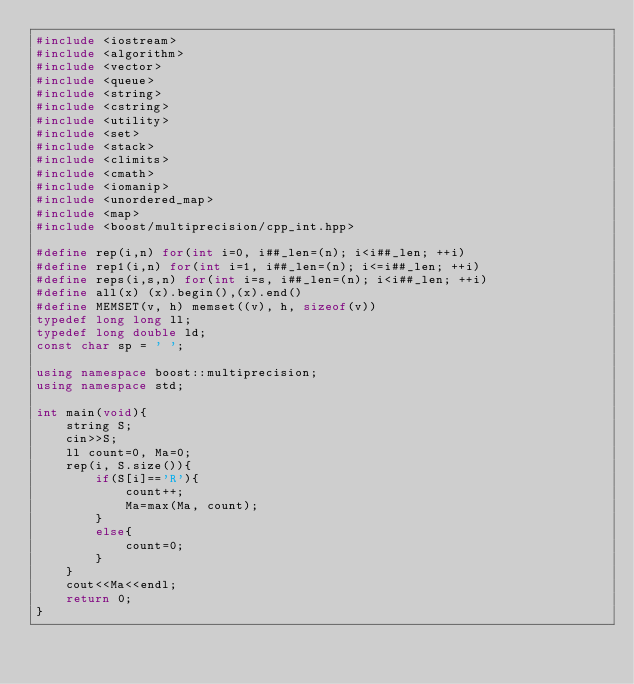<code> <loc_0><loc_0><loc_500><loc_500><_C++_>#include <iostream>
#include <algorithm>
#include <vector>
#include <queue>
#include <string>
#include <cstring>
#include <utility>
#include <set>
#include <stack>
#include <climits>
#include <cmath>
#include <iomanip>
#include <unordered_map>
#include <map>
#include <boost/multiprecision/cpp_int.hpp>

#define rep(i,n) for(int i=0, i##_len=(n); i<i##_len; ++i)
#define rep1(i,n) for(int i=1, i##_len=(n); i<=i##_len; ++i)
#define reps(i,s,n) for(int i=s, i##_len=(n); i<i##_len; ++i)
#define all(x) (x).begin(),(x).end()
#define MEMSET(v, h) memset((v), h, sizeof(v))
typedef long long ll;
typedef long double ld;
const char sp = ' ';

using namespace boost::multiprecision;
using namespace std;

int main(void){
    string S;
    cin>>S;
    ll count=0, Ma=0;
    rep(i, S.size()){
        if(S[i]=='R'){
            count++;
            Ma=max(Ma, count);
        }
        else{
            count=0;
        }
    }
    cout<<Ma<<endl;
    return 0;
}
</code> 